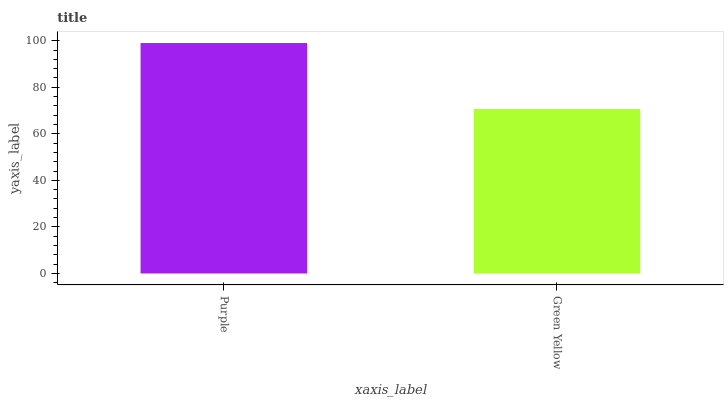Is Green Yellow the maximum?
Answer yes or no. No. Is Purple greater than Green Yellow?
Answer yes or no. Yes. Is Green Yellow less than Purple?
Answer yes or no. Yes. Is Green Yellow greater than Purple?
Answer yes or no. No. Is Purple less than Green Yellow?
Answer yes or no. No. Is Purple the high median?
Answer yes or no. Yes. Is Green Yellow the low median?
Answer yes or no. Yes. Is Green Yellow the high median?
Answer yes or no. No. Is Purple the low median?
Answer yes or no. No. 